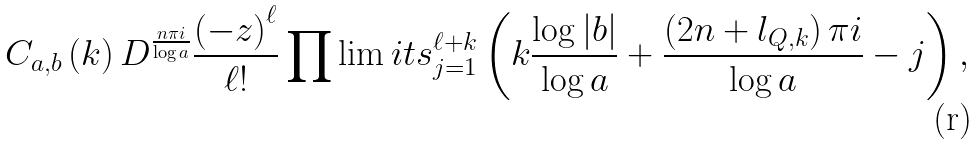Convert formula to latex. <formula><loc_0><loc_0><loc_500><loc_500>C _ { a , b } \left ( k \right ) D ^ { \frac { n \pi i } { \log a } } \frac { \left ( - z \right ) ^ { \ell } } { \ell ! } \prod \lim i t s _ { j = 1 } ^ { \ell + k } \left ( k \frac { \log | b | } { \log a } + \frac { \left ( 2 n + l _ { Q , k } \right ) \pi i } { \log a } - j \right ) ,</formula> 